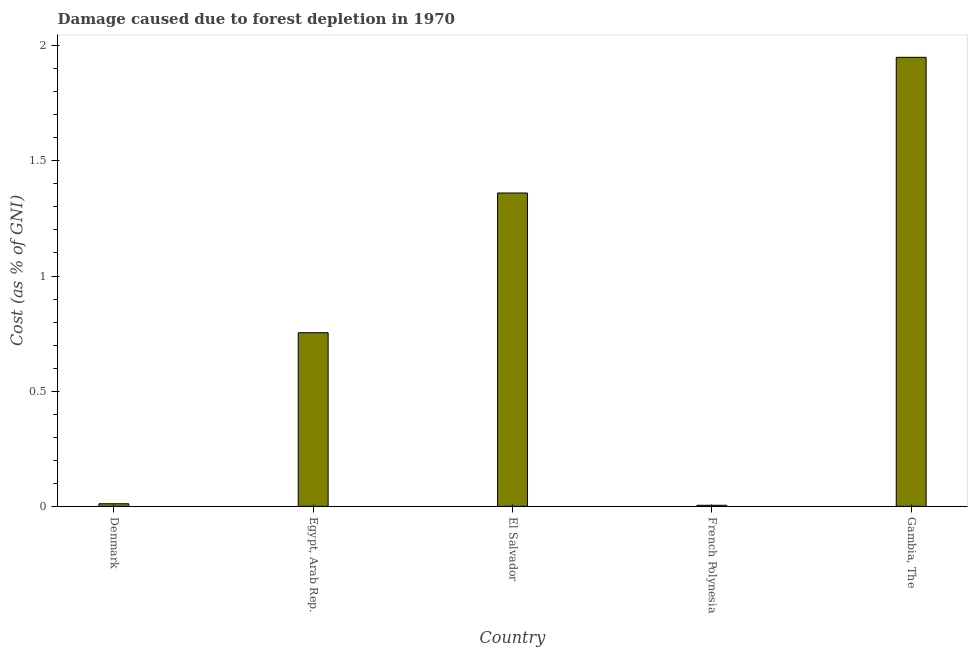Does the graph contain any zero values?
Keep it short and to the point. No. What is the title of the graph?
Make the answer very short. Damage caused due to forest depletion in 1970. What is the label or title of the Y-axis?
Offer a very short reply. Cost (as % of GNI). What is the damage caused due to forest depletion in French Polynesia?
Ensure brevity in your answer.  0. Across all countries, what is the maximum damage caused due to forest depletion?
Provide a short and direct response. 1.95. Across all countries, what is the minimum damage caused due to forest depletion?
Offer a terse response. 0. In which country was the damage caused due to forest depletion maximum?
Offer a terse response. Gambia, The. In which country was the damage caused due to forest depletion minimum?
Give a very brief answer. French Polynesia. What is the sum of the damage caused due to forest depletion?
Your answer should be very brief. 4.08. What is the difference between the damage caused due to forest depletion in El Salvador and French Polynesia?
Your answer should be very brief. 1.36. What is the average damage caused due to forest depletion per country?
Your answer should be very brief. 0.82. What is the median damage caused due to forest depletion?
Give a very brief answer. 0.75. What is the ratio of the damage caused due to forest depletion in Denmark to that in Gambia, The?
Your response must be concise. 0.01. What is the difference between the highest and the second highest damage caused due to forest depletion?
Your answer should be very brief. 0.59. Is the sum of the damage caused due to forest depletion in El Salvador and French Polynesia greater than the maximum damage caused due to forest depletion across all countries?
Give a very brief answer. No. What is the difference between the highest and the lowest damage caused due to forest depletion?
Provide a succinct answer. 1.94. In how many countries, is the damage caused due to forest depletion greater than the average damage caused due to forest depletion taken over all countries?
Give a very brief answer. 2. How many bars are there?
Keep it short and to the point. 5. Are all the bars in the graph horizontal?
Provide a short and direct response. No. What is the difference between two consecutive major ticks on the Y-axis?
Offer a very short reply. 0.5. What is the Cost (as % of GNI) of Denmark?
Your answer should be very brief. 0.01. What is the Cost (as % of GNI) of Egypt, Arab Rep.?
Provide a succinct answer. 0.75. What is the Cost (as % of GNI) of El Salvador?
Your answer should be very brief. 1.36. What is the Cost (as % of GNI) in French Polynesia?
Provide a succinct answer. 0. What is the Cost (as % of GNI) of Gambia, The?
Keep it short and to the point. 1.95. What is the difference between the Cost (as % of GNI) in Denmark and Egypt, Arab Rep.?
Your answer should be compact. -0.74. What is the difference between the Cost (as % of GNI) in Denmark and El Salvador?
Make the answer very short. -1.35. What is the difference between the Cost (as % of GNI) in Denmark and French Polynesia?
Your response must be concise. 0.01. What is the difference between the Cost (as % of GNI) in Denmark and Gambia, The?
Your answer should be very brief. -1.94. What is the difference between the Cost (as % of GNI) in Egypt, Arab Rep. and El Salvador?
Provide a short and direct response. -0.61. What is the difference between the Cost (as % of GNI) in Egypt, Arab Rep. and French Polynesia?
Make the answer very short. 0.75. What is the difference between the Cost (as % of GNI) in Egypt, Arab Rep. and Gambia, The?
Provide a succinct answer. -1.2. What is the difference between the Cost (as % of GNI) in El Salvador and French Polynesia?
Provide a succinct answer. 1.36. What is the difference between the Cost (as % of GNI) in El Salvador and Gambia, The?
Your response must be concise. -0.59. What is the difference between the Cost (as % of GNI) in French Polynesia and Gambia, The?
Provide a succinct answer. -1.94. What is the ratio of the Cost (as % of GNI) in Denmark to that in Egypt, Arab Rep.?
Keep it short and to the point. 0.01. What is the ratio of the Cost (as % of GNI) in Denmark to that in El Salvador?
Your answer should be compact. 0.01. What is the ratio of the Cost (as % of GNI) in Denmark to that in French Polynesia?
Keep it short and to the point. 2.43. What is the ratio of the Cost (as % of GNI) in Denmark to that in Gambia, The?
Your answer should be very brief. 0.01. What is the ratio of the Cost (as % of GNI) in Egypt, Arab Rep. to that in El Salvador?
Your answer should be very brief. 0.55. What is the ratio of the Cost (as % of GNI) in Egypt, Arab Rep. to that in French Polynesia?
Provide a short and direct response. 162.96. What is the ratio of the Cost (as % of GNI) in Egypt, Arab Rep. to that in Gambia, The?
Offer a very short reply. 0.39. What is the ratio of the Cost (as % of GNI) in El Salvador to that in French Polynesia?
Your response must be concise. 294.09. What is the ratio of the Cost (as % of GNI) in El Salvador to that in Gambia, The?
Make the answer very short. 0.7. What is the ratio of the Cost (as % of GNI) in French Polynesia to that in Gambia, The?
Provide a short and direct response. 0. 